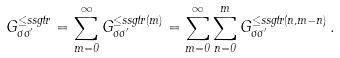Convert formula to latex. <formula><loc_0><loc_0><loc_500><loc_500>G _ { \sigma \sigma ^ { \prime } } ^ { \leq s s g t r } = \sum _ { m = 0 } ^ { \infty } G _ { \sigma \sigma ^ { \prime } } ^ { \leq s s g t r ( m ) } = \sum _ { m = 0 } ^ { \infty } \sum _ { n = 0 } ^ { m } G _ { \sigma \sigma ^ { \prime } } ^ { \leq s s g t r ( n , m - n ) } \, .</formula> 